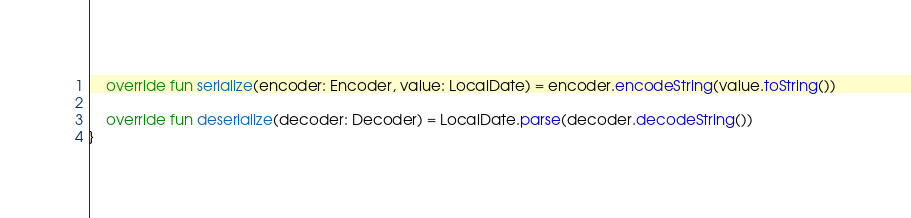Convert code to text. <code><loc_0><loc_0><loc_500><loc_500><_Kotlin_>    override fun serialize(encoder: Encoder, value: LocalDate) = encoder.encodeString(value.toString())

    override fun deserialize(decoder: Decoder) = LocalDate.parse(decoder.decodeString())
}
</code> 